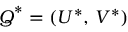<formula> <loc_0><loc_0><loc_500><loc_500>Q ^ { * } = \left ( U ^ { * } , \, V ^ { * } \right )</formula> 